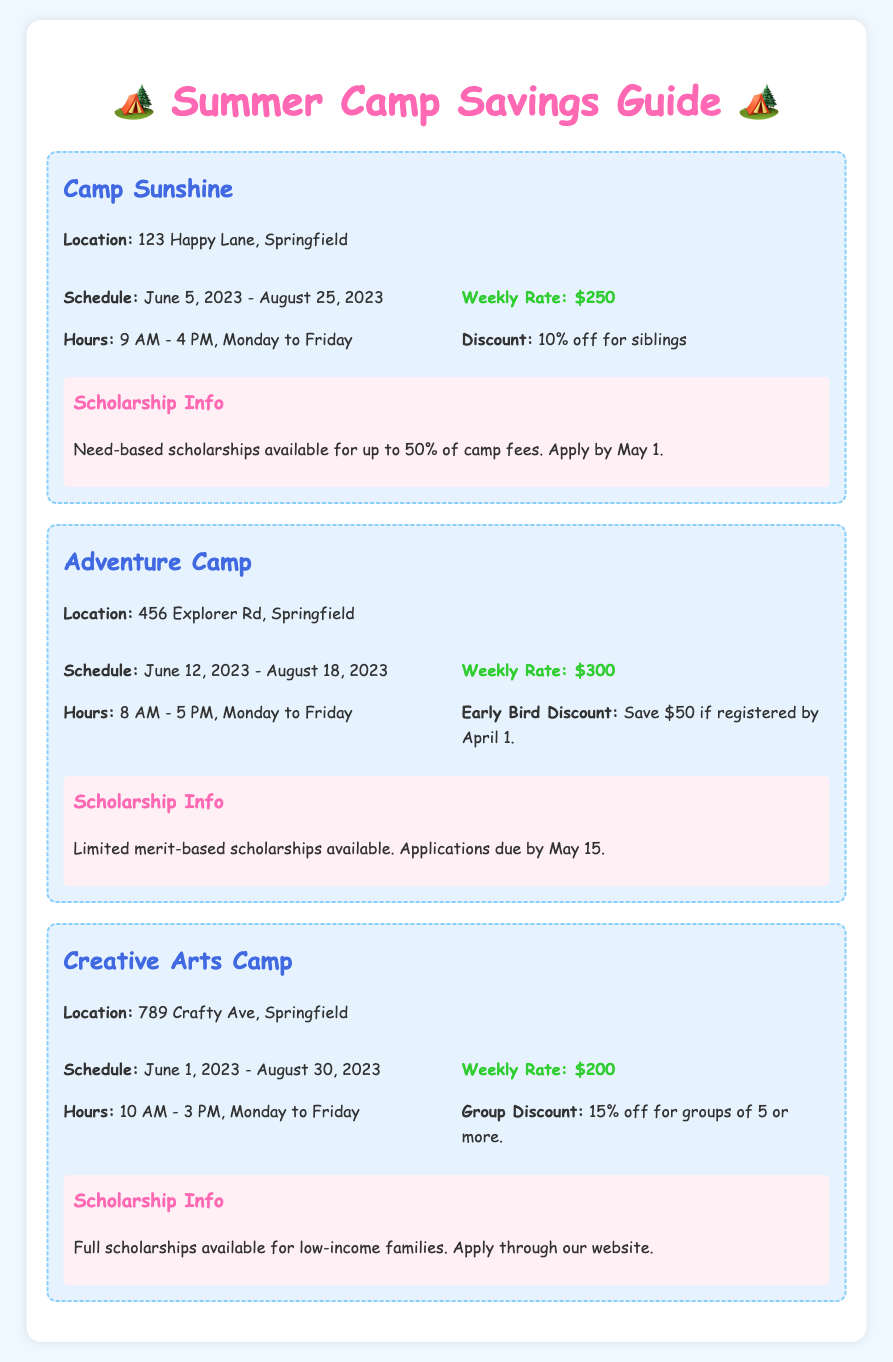What is the location of Camp Sunshine? The document states that Camp Sunshine is located at 123 Happy Lane, Springfield.
Answer: 123 Happy Lane, Springfield What is the weekly rate for Creative Arts Camp? According to the document, the weekly rate for Creative Arts Camp is listed as $200.
Answer: $200 What percentage discount is offered for siblings at Camp Sunshine? The document mentions a 10% off discount for siblings at Camp Sunshine.
Answer: 10% off What is the application deadline for scholarships at Adventure Camp? The document states that the application deadline for scholarships at Adventure Camp is May 15.
Answer: May 15 How long is the schedule for Adventure Camp? The document indicates that Adventure Camp runs from June 12, 2023 to August 18, 2023.
Answer: June 12, 2023 - August 18, 2023 What are the operating hours for Creative Arts Camp? According to the document, Creative Arts Camp operates from 10 AM to 3 PM, Monday to Friday.
Answer: 10 AM - 3 PM, Monday to Friday What type of scholarships are available at Creative Arts Camp? The document specifies that full scholarships are available for low-income families.
Answer: Full scholarships for low-income families What is the early bird discount amount for Adventure Camp? The document states that the early bird discount is $50 if registered by April 1.
Answer: $50 What is the group discount percentage at Creative Arts Camp? The document mentions a 15% off discount for groups of 5 or more at Creative Arts Camp.
Answer: 15% off 